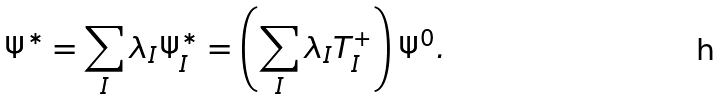<formula> <loc_0><loc_0><loc_500><loc_500>\Psi ^ { \ast } = \sum _ { I } \lambda _ { I } \Psi _ { I } ^ { \ast } = \left ( \sum _ { I } \lambda _ { I } T _ { I } ^ { + } \right ) \Psi ^ { 0 } .</formula> 